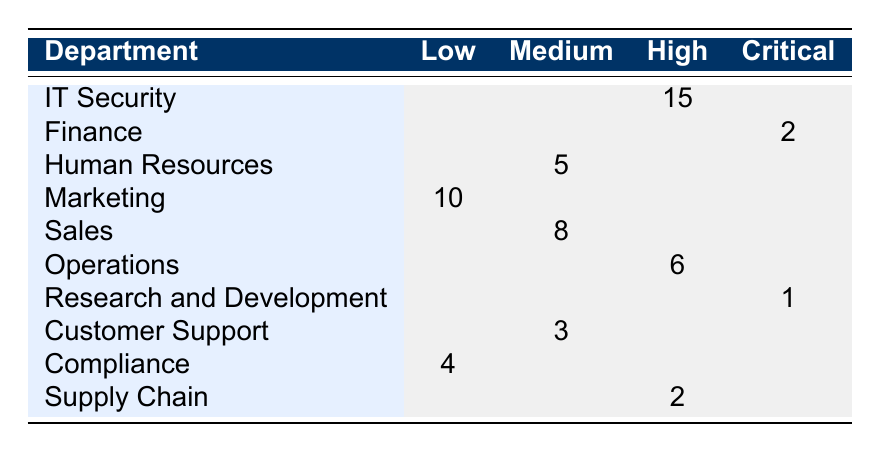What is the total number of incidents reported by the IT Security department? The IT Security department has 15 incidents reported under the high severity level. There are no incidents in the low and medium severity levels, and zero in critical severity as well. Therefore, the total incidents for IT Security is 15.
Answer: 15 Which department reported the highest number of critical incidents? The Finance department reported 2 incidents classified as critical, while the Research and Development department reported only 1. No other departments reported critical incidents, making Finance the department with the highest count.
Answer: Finance How many total incidents were reported across all departments in the low severity level? The Marketing department reported 10 incidents, and the Compliance department reported 4 incidents under the low severity level. Adding these gives 10 + 4 = 14.
Answer: 14 Which department has medium severity incidents, and what is the total count of those incidents? The departments with medium severity incidents are Human Resources with 5 incidents, Sales with 8 incidents, and Customer Support with 3 incidents. Adding these counts gives 5 + 8 + 3 = 16.
Answer: 16 Is there any department that reported both high and medium severity incidents? Reviewing the table reveals that the Operations department has 6 incidents under high severity but none listed under medium severity. Therefore, there is no department reporting both severity levels.
Answer: No Which severity level has the least total incidents across all departments? Summing the incidents, the low severity has 14 incidents (10 from Marketing + 4 from Compliance), medium has 16, high has 23 (15 from IT Security + 6 from Operations + 2 from Supply Chain), and critical has 3 (2 from Finance + 1 from Research and Development). Thus, the critical severity level has the least incidents.
Answer: Critical What is the difference in incident counts between medium and high severity incidents across all departments? Total medium severity incidents are 16 and total high severity incidents are 23. The difference is calculated as 23 - 16 = 7.
Answer: 7 Which department had the least amount of incident reports overall? The Research and Development department had just 1 incident report, which is less than any other department.
Answer: Research and Development Which type of incident was most reported in the medium severity category, and from which department? In the medium severity category, Sales department reported 8 incidents, which is the highest, while Human Resources reported 5 and Customer Support reported 3. Therefore, Sales department had the most reports.
Answer: Sales Did any department report a cybersecurity incident in the critical severity level without any incidents in other categories? The Research and Development department reported a single incident categorized as critical and did not report any incidents in low, medium, or high severity categories. Thus, it fits the criteria.
Answer: Yes 